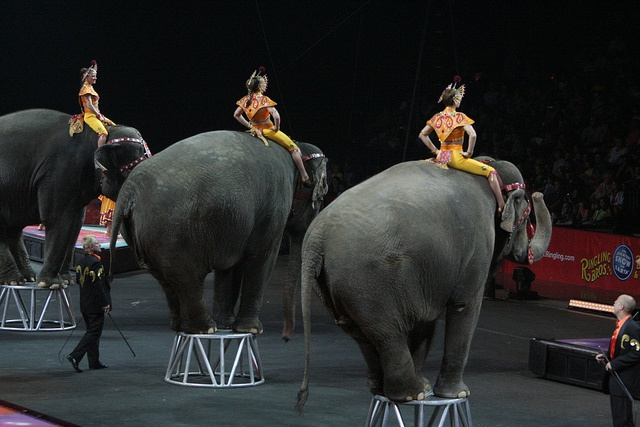Describe the objects in this image and their specific colors. I can see elephant in black and gray tones, elephant in black and gray tones, elephant in black, gray, and maroon tones, people in black, gray, tan, and brown tones, and people in black, gray, and darkgray tones in this image. 